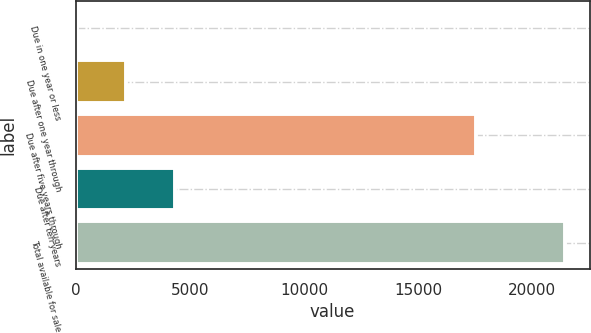<chart> <loc_0><loc_0><loc_500><loc_500><bar_chart><fcel>Due in one year or less<fcel>Due after one year through<fcel>Due after five years through<fcel>Due after ten years<fcel>Total available for sale<nl><fcel>66<fcel>2203.1<fcel>17516<fcel>4340.2<fcel>21437<nl></chart> 